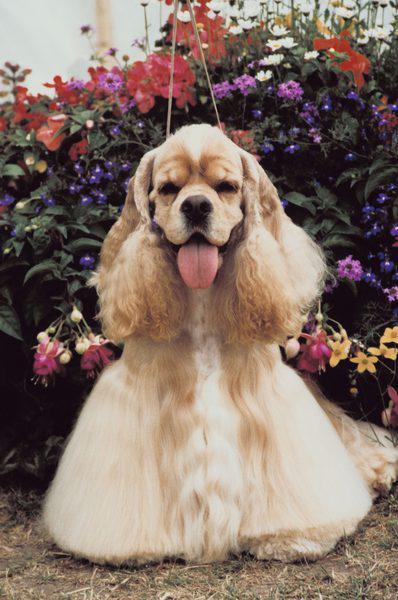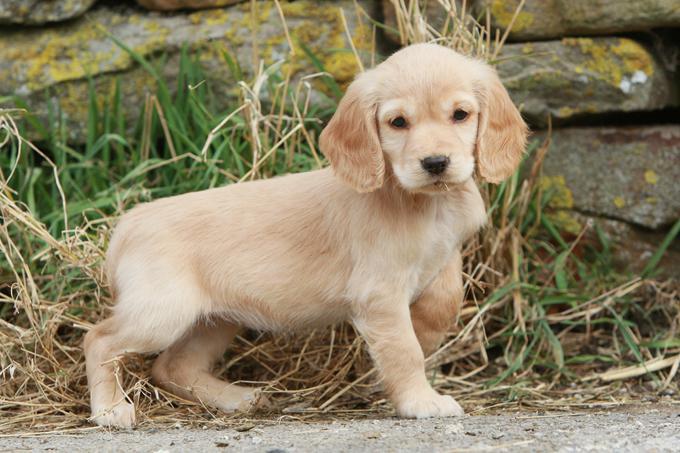The first image is the image on the left, the second image is the image on the right. For the images displayed, is the sentence "The left image shows a spaniel with its body in profile." factually correct? Answer yes or no. No. 